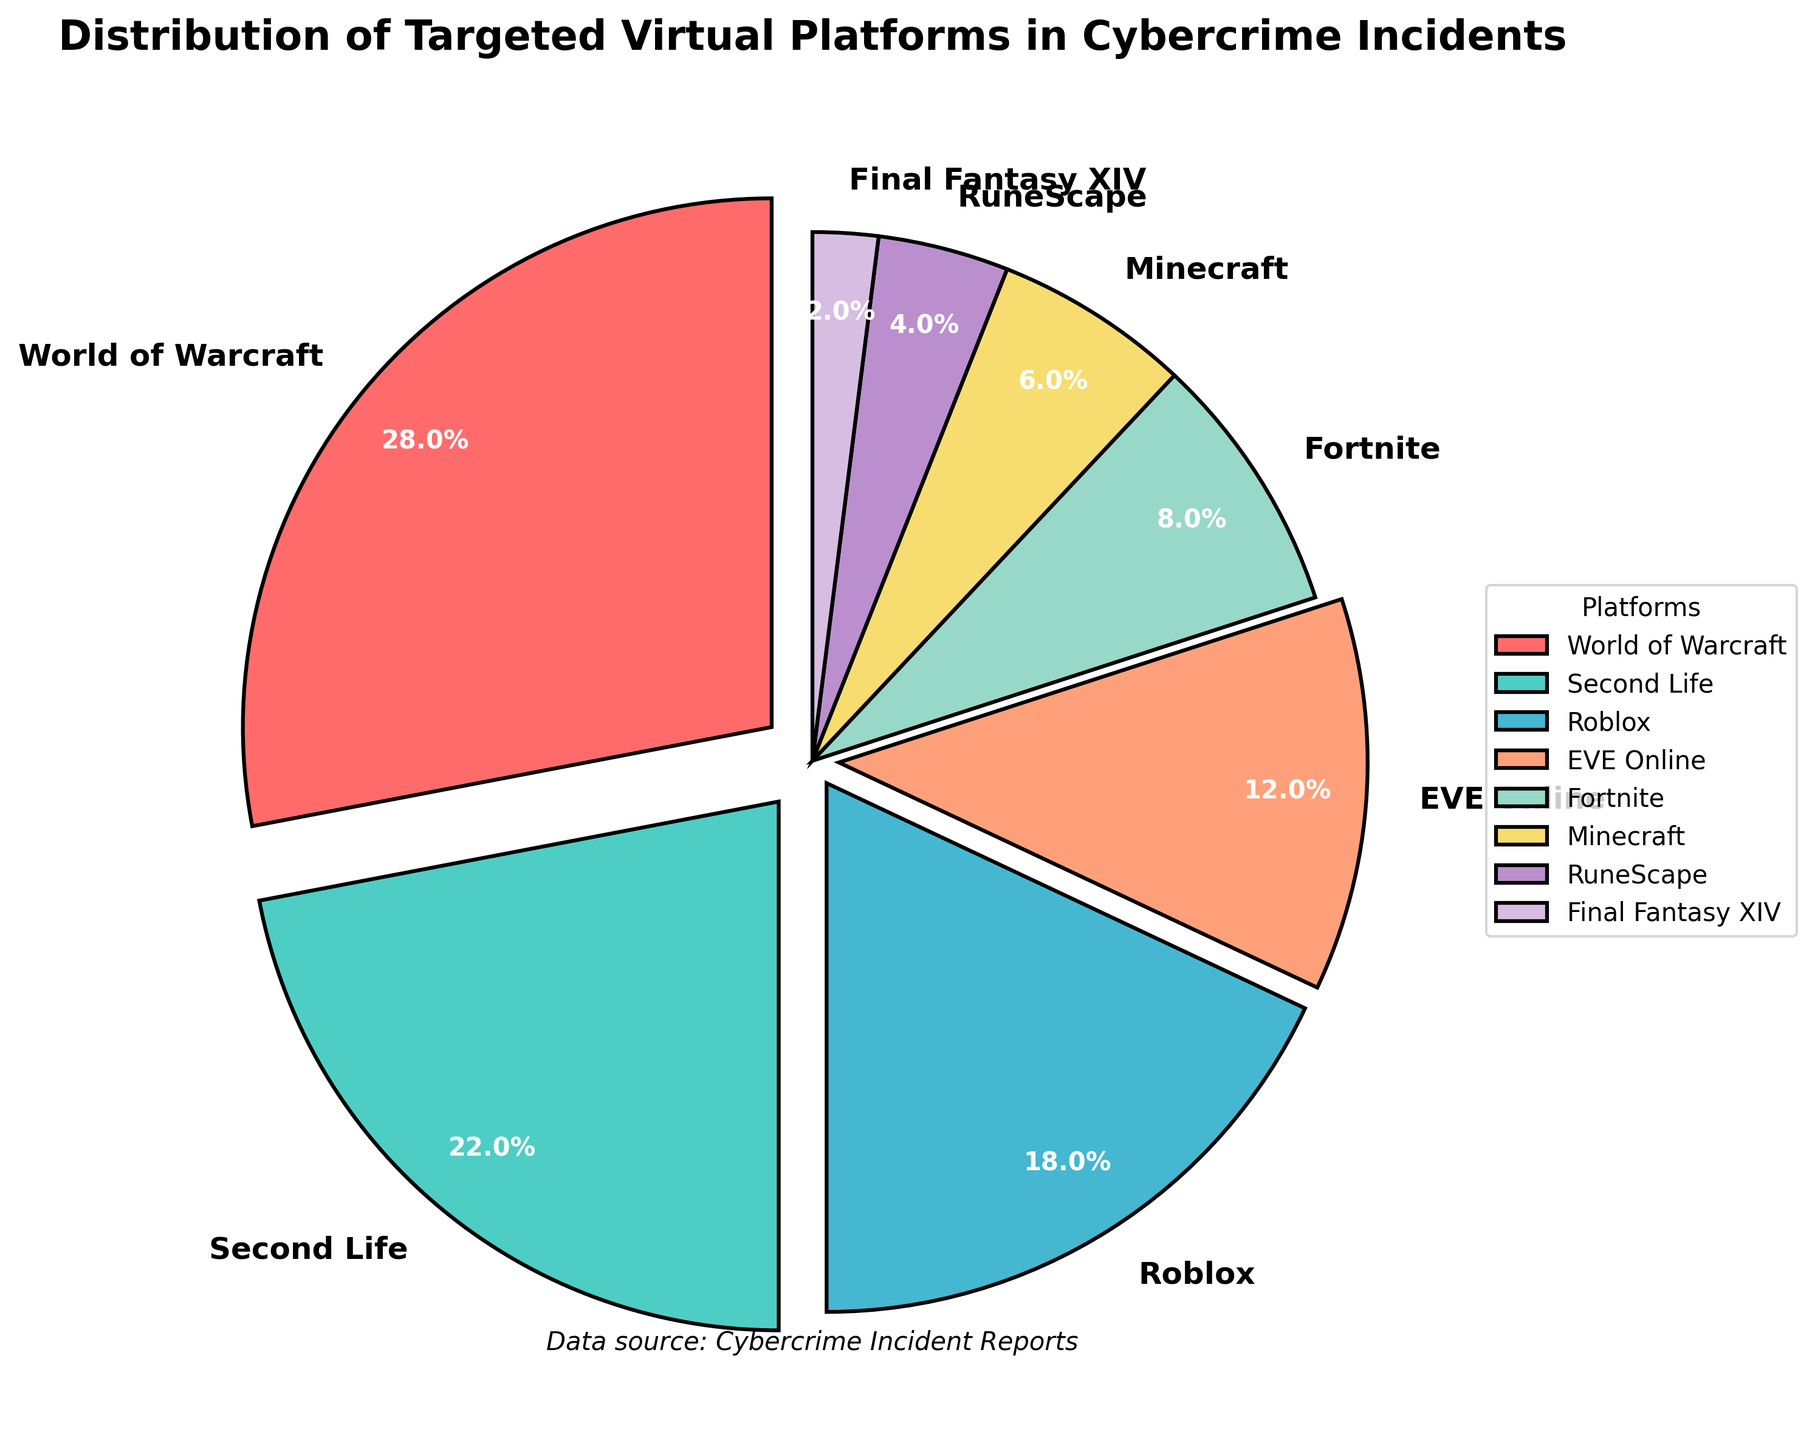Which platform has the highest percentage of targeted cybercrime incidents? Look at the slice of the pie chart with the largest size. The label on it indicates "World of Warcraft" with 28%.
Answer: World of Warcraft What is the combined percentage of cybercrime incidents targeting EVE Online and Fortnite? According to the chart, EVE Online has 12% and Fortnite has 8%. Adding these percentages together: 12% + 8% = 20%.
Answer: 20% Which virtual platform has a higher percentage of targeted incidents: Minecraft or Roblox? Comparing the slices, Roblox has 18% while Minecraft has 6%. Therefore, Roblox has a higher percentage.
Answer: Roblox How many platforms have a percentage of targeted incidents greater than or equal to 10%? Identify the slices labeled with 10% or higher: World of Warcraft (28%), Second Life (22%), and Roblox (18%), and EVE Online (12%). There are 4 platforms.
Answer: 4 platforms What is the difference in the percentage of targeted incidents between RuneScape and Final Fantasy XIV? RuneScape has 4% and Final Fantasy XIV has 2%. The difference is calculated as 4% - 2% = 2%.
Answer: 2% What is the average percentage of targeted incidents for platforms with less than 10% of the incidents? The platforms are Fortnite (8%), Minecraft (6%), RuneScape (4%), and Final Fantasy XIV (2%). Adding these: 8% + 6% + 4% + 2% = 20%. Then, divide by the number of these platforms (4): 20%/4 = 5%.
Answer: 5% Which color represents the Second Life platform in the pie chart? Identify the color of the pie slice labeled "Second Life." It is light cyan (#4ECDC4).
Answer: light cyan How much larger is the percentage of incidents targeting World of Warcraft compared to RuneScape? World of Warcraft has 28%, and RuneScape has 4%. The difference is calculated as 28% - 4% = 24%.
Answer: 24% If you combine the percentages of cybercrime incidents targeting Roblox and EVE Online, do they surpass the percentage targeting Second Life? Roblox has 18% and EVE Online has 12%. Adding them gives 18% + 12% = 30%, which is greater than Second Life's 22%.
Answer: Yes What two platforms have equal differences in their percentage of targeted incidents compared to Minecraft? The two platforms need differences in their percentages to match Minecraft's percentage (6%). RuneScape (4%) differs by 2% from Minecraft, and Final Fantasy XIV (2%) also differs by 2%.
Answer: RuneScape and Final Fantasy XIV 